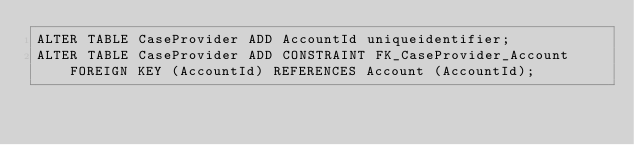<code> <loc_0><loc_0><loc_500><loc_500><_SQL_>ALTER TABLE CaseProvider ADD AccountId uniqueidentifier;
ALTER TABLE CaseProvider ADD CONSTRAINT FK_CaseProvider_Account FOREIGN KEY (AccountId) REFERENCES Account (AccountId);
</code> 